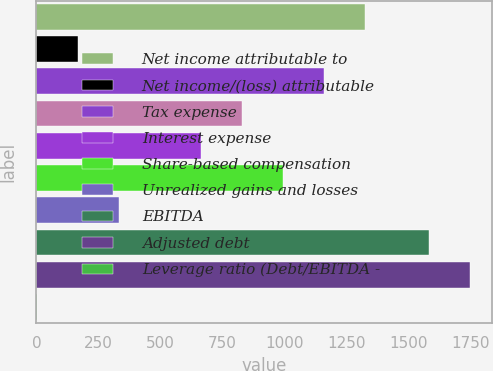Convert chart to OTSL. <chart><loc_0><loc_0><loc_500><loc_500><bar_chart><fcel>Net income attributable to<fcel>Net income/(loss) attributable<fcel>Tax expense<fcel>Unnamed: 3<fcel>Interest expense<fcel>Share-based compensation<fcel>Unrealized gains and losses<fcel>EBITDA<fcel>Adjusted debt<fcel>Leverage ratio (Debt/EBITDA -<nl><fcel>1324.38<fcel>166.47<fcel>1158.96<fcel>828.13<fcel>662.72<fcel>993.55<fcel>331.88<fcel>1582.7<fcel>1748.12<fcel>1.05<nl></chart> 